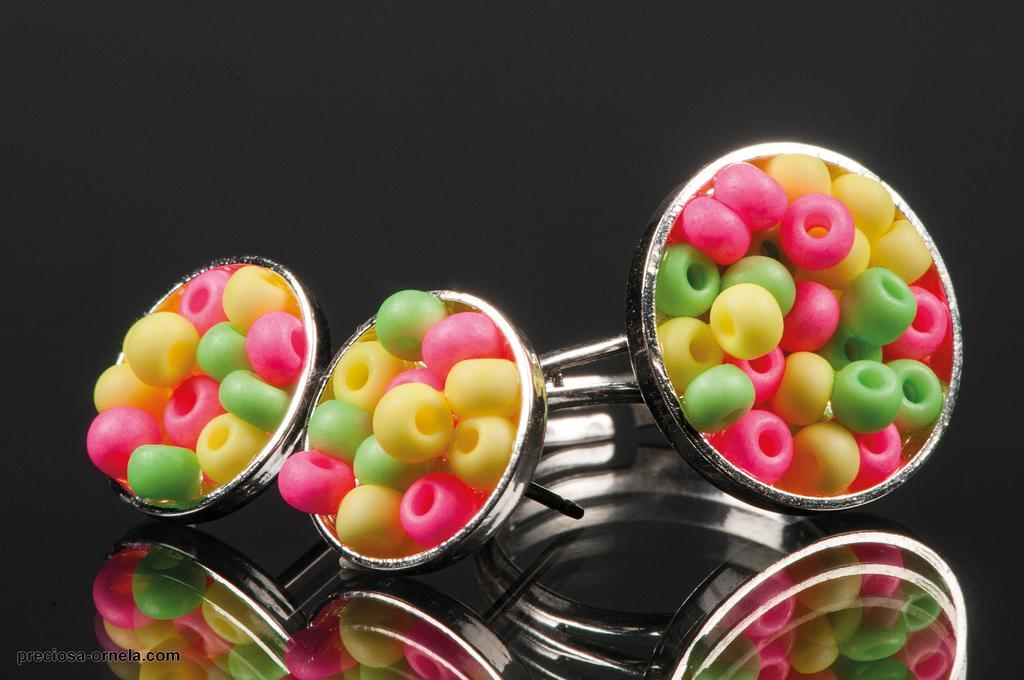What is located in the center of the image? There are three rings in the center of the image. What can be found inside the rings? There are objects present in the rings. How many cacti can be seen growing in the rings? There are no cacti present in the image; the rings contain objects, but no plants. 